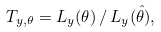Convert formula to latex. <formula><loc_0><loc_0><loc_500><loc_500>T _ { y , \theta } = L _ { y } ( \theta ) \, / \, L _ { y } ( \hat { \theta } ) ,</formula> 